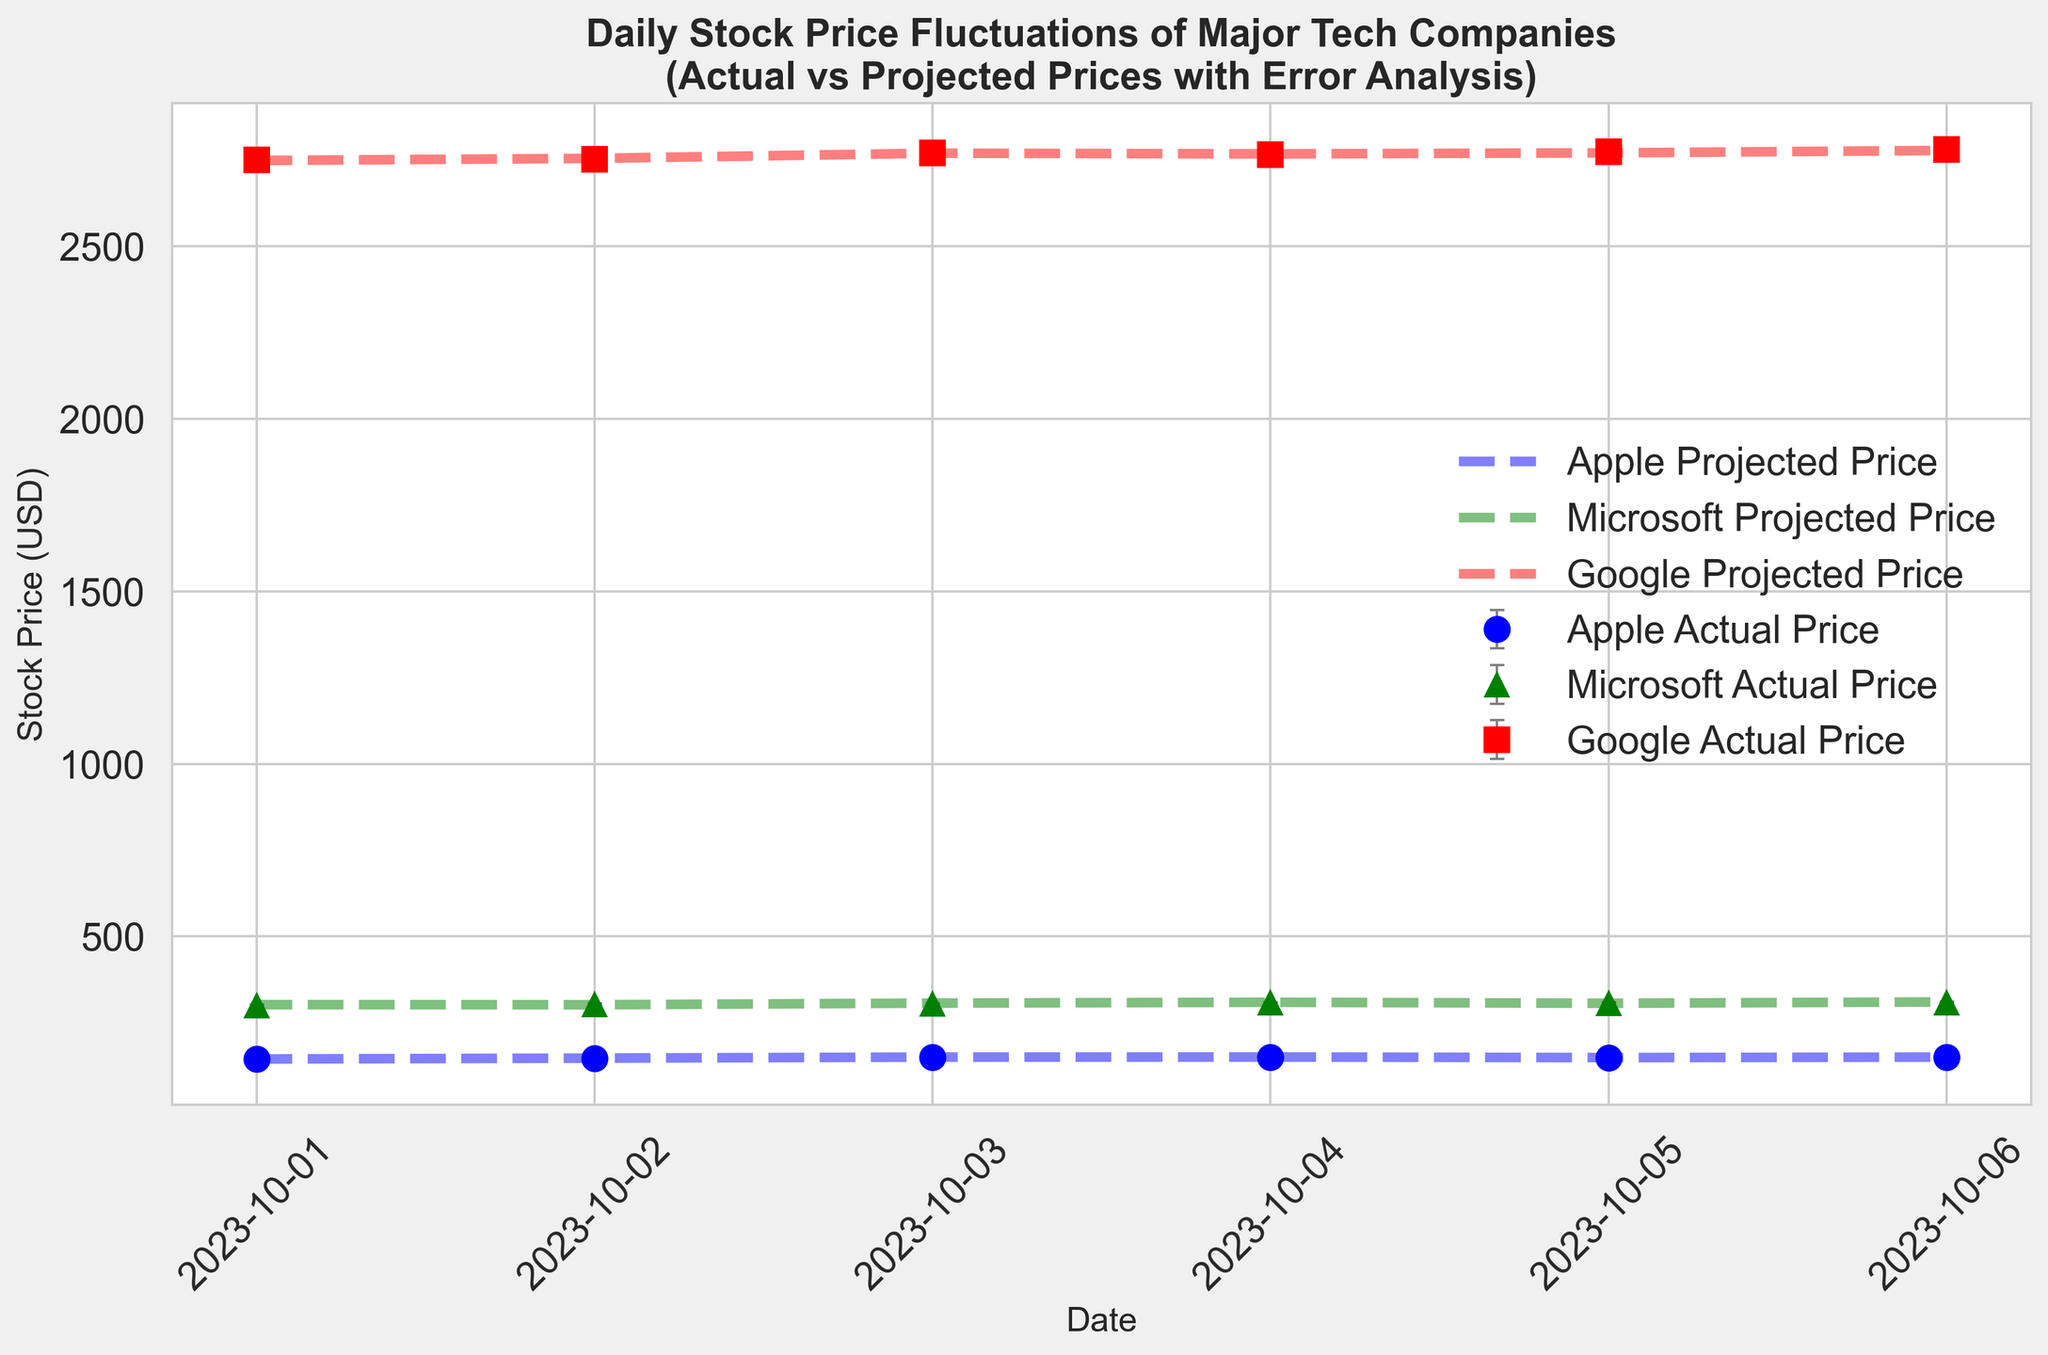What is the stock price fluctuation range (difference between the highest and lowest actual prices) for Apple between October 1 and October 6, 2023? From the figure, identify the highest and lowest actual prices for Apple during the period. The highest actual price for Apple is 149.70 USD, and the lowest actual price is 145.23 USD. The fluctuation range is the difference: 149.70 - 145.23 = 4.47 USD.
Answer: 4.47 USD On which date was the error in the projected price of Microsoft the largest and what was the magnitude of the error? Look for the day with the largest error for Microsoft by visually comparing the error bars. The date with the largest error is October 1, 2023, with an error magnitude of 1.55.
Answer: October 1, 2023, 1.55 USD How does the actual stock price of Google on October 5, 2023, compare to its projected price on the same date? Observe the figure for October 5, 2023, and compare the actual price of Google (shown with an error bar) to the projected price (dashed line). The actual price is 2773.40 USD, and the projected price is 2771.00 USD. The actual price is higher than the projected price by 2.4 USD.
Answer: 2.4 USD higher Which company had the smallest error (absolute value) in its projected stock price on October 4, 2023? Compare the length of the error bars for all companies on October 4, 2023. The smallest error bar belongs to Microsoft with an error of 0.70 USD.
Answer: Microsoft Calculate the average error for Google between October 1 and October 6, 2023. Sum the absolute values of the errors for Google over the six days: 1.77 + 1.90 + 1.55 + 2.20 + 2.40 + 2.60 = 12.42. Divide this sum by the number of days (6): 12.42 / 6 = 2.07 USD.
Answer: 2.07 USD On which date did Apple have the largest negative error, and what was the actual stock price on that date? Find the date where the error bar for Apple is the largest in the negative direction. The largest negative error for Apple is on October 3, 2023, with an error of -1.10. The actual stock price on that date is 148.90 USD.
Answer: October 3, 2023, 148.90 USD Compare the trend of the actual stock price of Microsoft to the projected stock price from October 1 to October 6, 2023. Are they mostly aligned or significantly different? Observe the lines and error bars for Microsoft's actual and projected prices over the period. Both lines exhibit a similar upward trend with slight discrepancies (e.g., October 2 and October 4). The trend shows that the overall alignment is quite close.
Answer: Mostly aligned How did the error in projected prices for Google on October 6, 2023, compare to the error on October 4, 2023? Compare the lengths of the error bars for Google on these dates. The error for October 6, 2023, is 2.60, and for October 4, 2023, it is 2.20. The error on October 6 is larger by 0.40.
Answer: 0.40 larger 